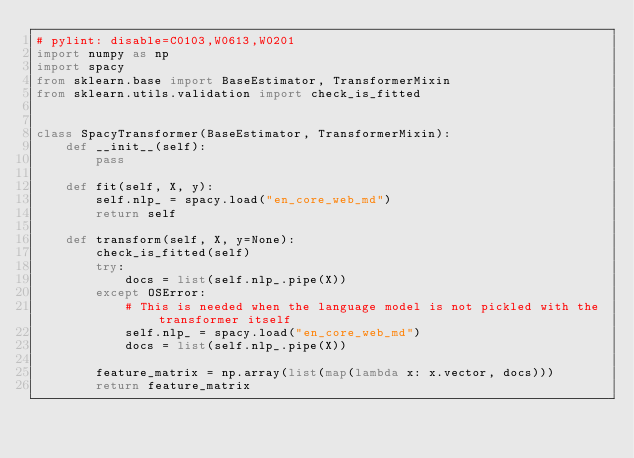<code> <loc_0><loc_0><loc_500><loc_500><_Python_># pylint: disable=C0103,W0613,W0201
import numpy as np
import spacy
from sklearn.base import BaseEstimator, TransformerMixin
from sklearn.utils.validation import check_is_fitted


class SpacyTransformer(BaseEstimator, TransformerMixin):
    def __init__(self):
        pass

    def fit(self, X, y):
        self.nlp_ = spacy.load("en_core_web_md")
        return self

    def transform(self, X, y=None):
        check_is_fitted(self)
        try:
            docs = list(self.nlp_.pipe(X))
        except OSError:
            # This is needed when the language model is not pickled with the transformer itself
            self.nlp_ = spacy.load("en_core_web_md")
            docs = list(self.nlp_.pipe(X))

        feature_matrix = np.array(list(map(lambda x: x.vector, docs)))
        return feature_matrix
</code> 